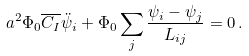<formula> <loc_0><loc_0><loc_500><loc_500>a ^ { 2 } \Phi _ { 0 } \overline { C _ { I } } \ddot { \psi } _ { i } + \Phi _ { 0 } \sum _ { j } \frac { \psi _ { i } - \psi _ { j } } { L _ { i j } } = 0 \, .</formula> 